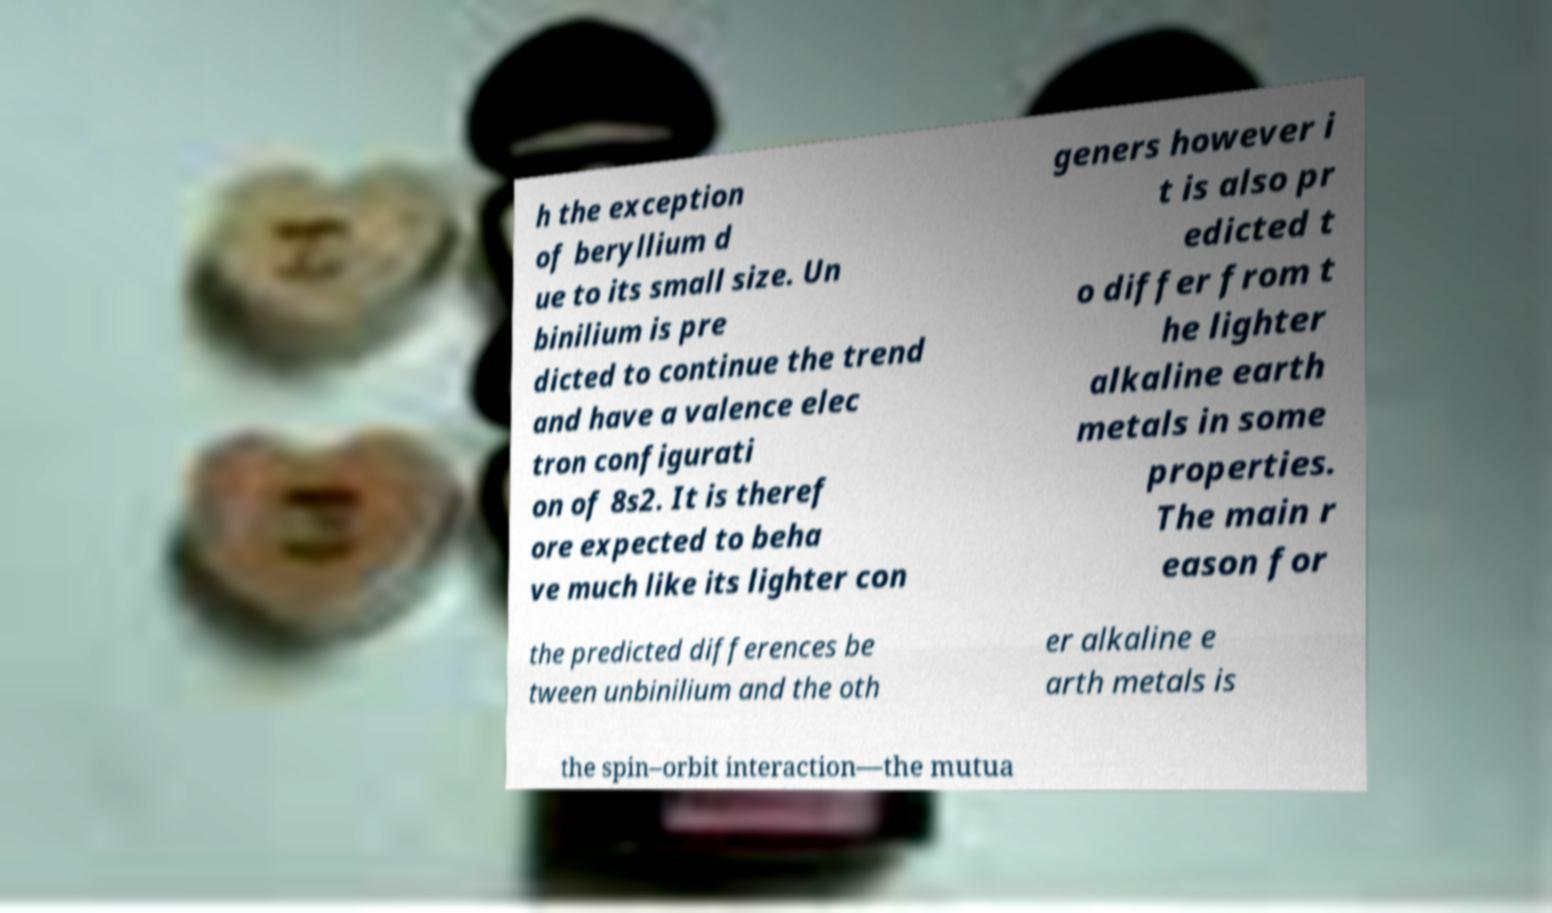For documentation purposes, I need the text within this image transcribed. Could you provide that? h the exception of beryllium d ue to its small size. Un binilium is pre dicted to continue the trend and have a valence elec tron configurati on of 8s2. It is theref ore expected to beha ve much like its lighter con geners however i t is also pr edicted t o differ from t he lighter alkaline earth metals in some properties. The main r eason for the predicted differences be tween unbinilium and the oth er alkaline e arth metals is the spin–orbit interaction—the mutua 